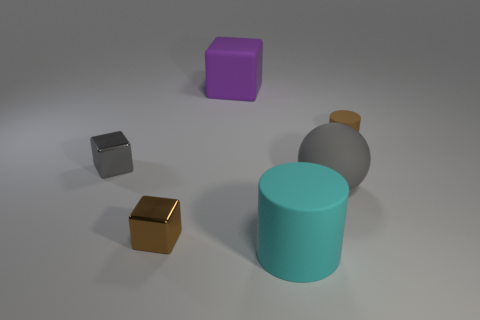Are there any repeating patterns or materials visible? The objects do not display any repeating patterns, but they do seem to share a common material characteristic, showing a smooth, somewhat reflective surface. 